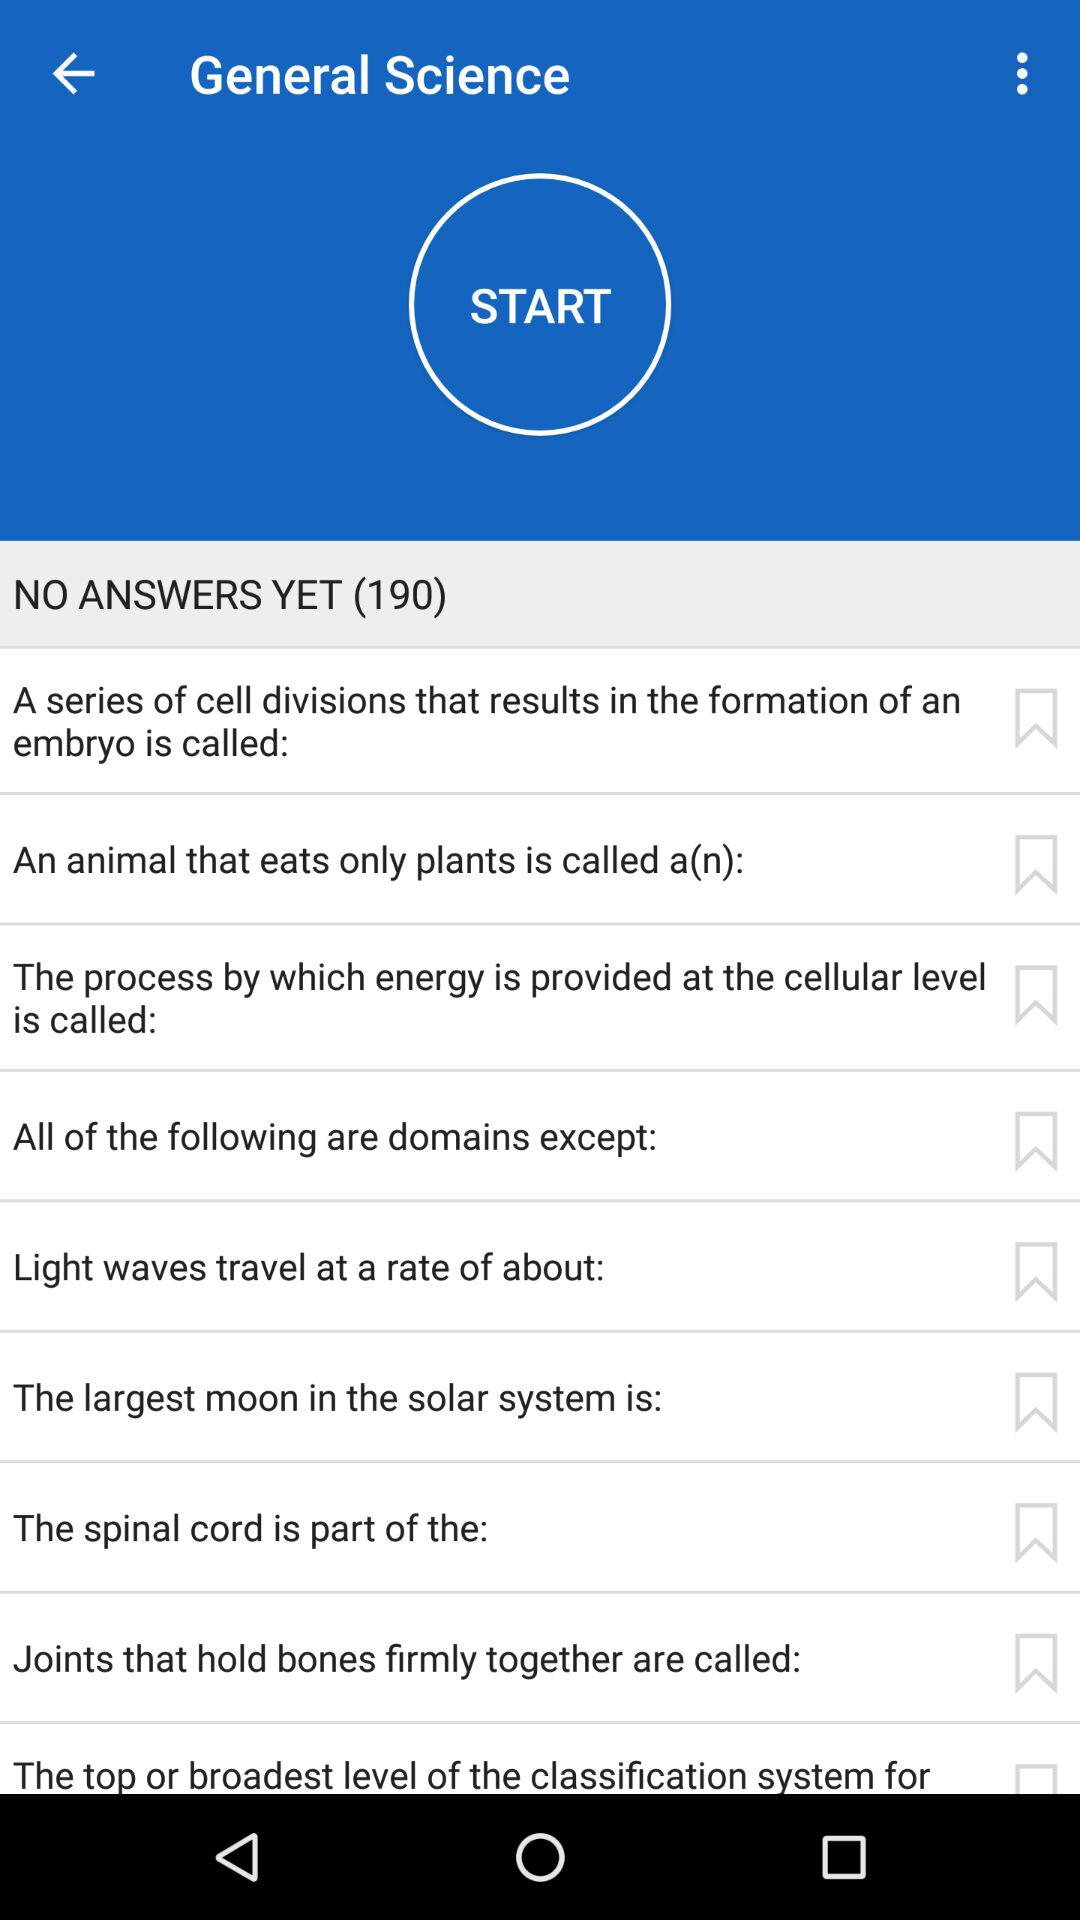How many answers have been displayed so far? There is no answer displayed yet. 